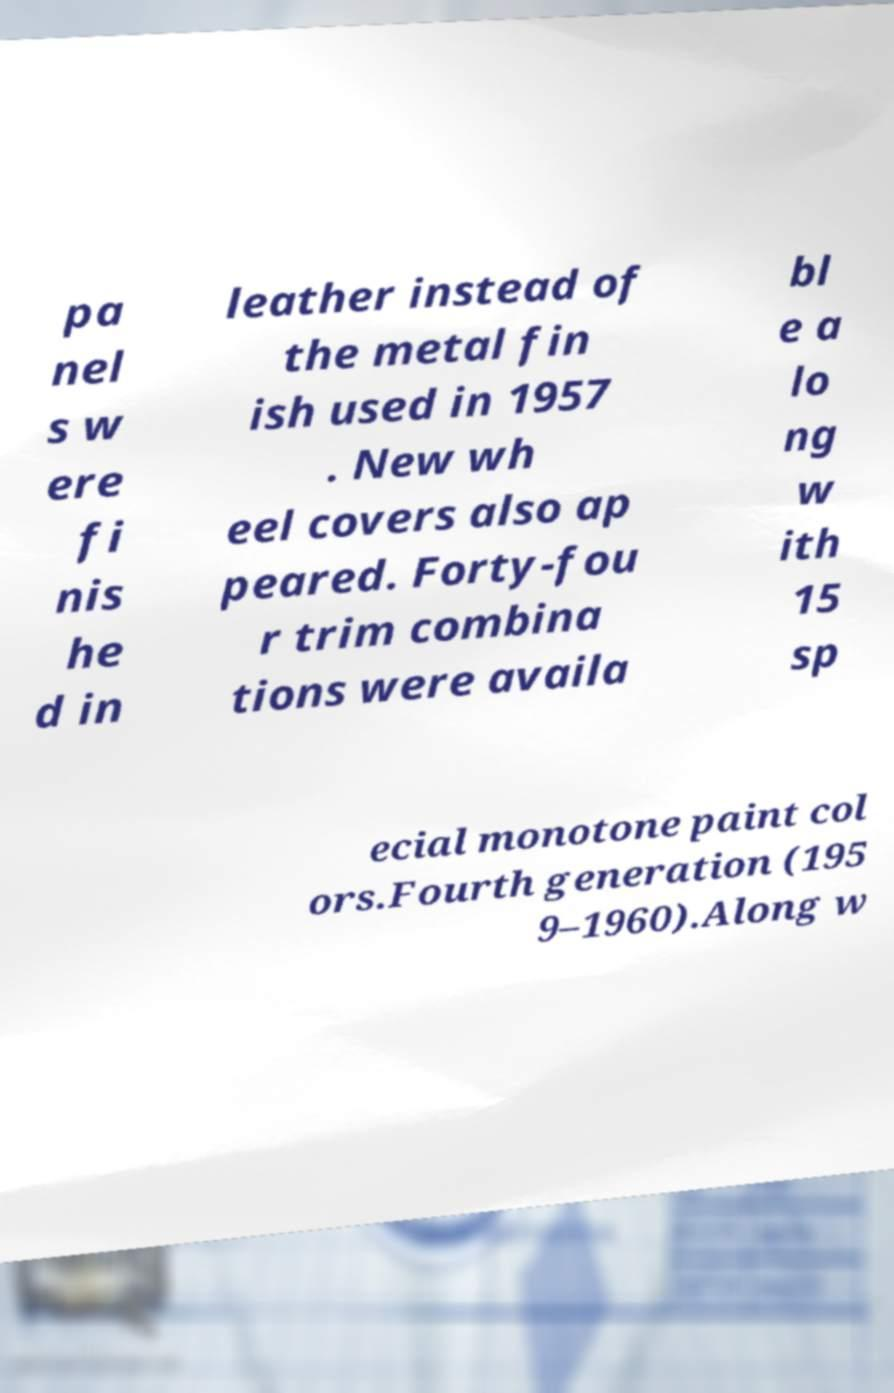Please identify and transcribe the text found in this image. pa nel s w ere fi nis he d in leather instead of the metal fin ish used in 1957 . New wh eel covers also ap peared. Forty-fou r trim combina tions were availa bl e a lo ng w ith 15 sp ecial monotone paint col ors.Fourth generation (195 9–1960).Along w 